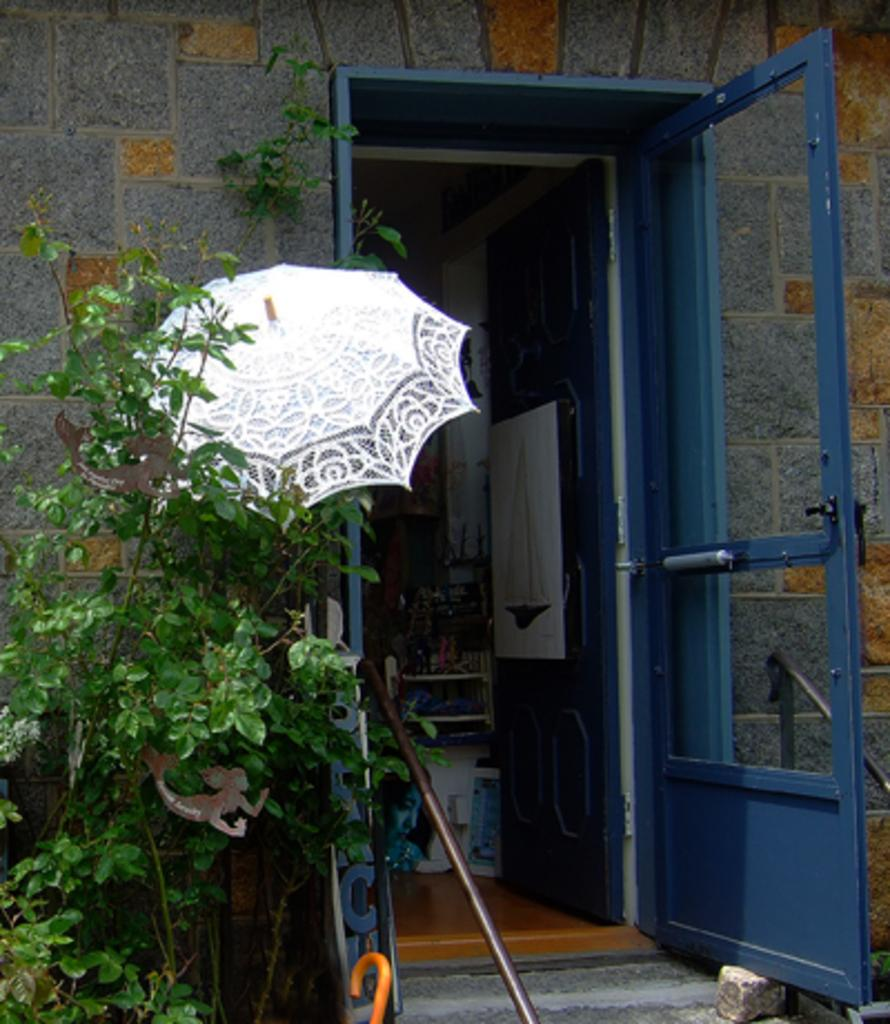What type of plant is on the left side of the image? There is a green color plant on the left side of the image. What is the color of the door in the middle of the image? There is a blue color door in the middle of the image. What can be seen inside the room visible in the image? The details of the room are not mentioned, but we know there is a room visible in the image. What color is the umbrella in the image? There is a white color umbrella in the image. What type of wall is present in the image? There is a stone wall in the image. What month is it in the image? The month is not mentioned or visible in the image. How many wheels are there in the image? There is no mention of any wheels in the image. 